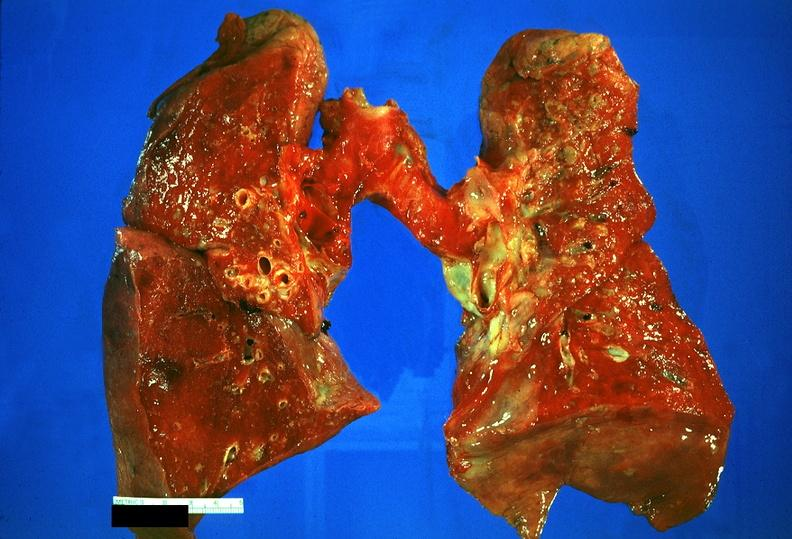does this image show lung, sarcoidosis?
Answer the question using a single word or phrase. Yes 